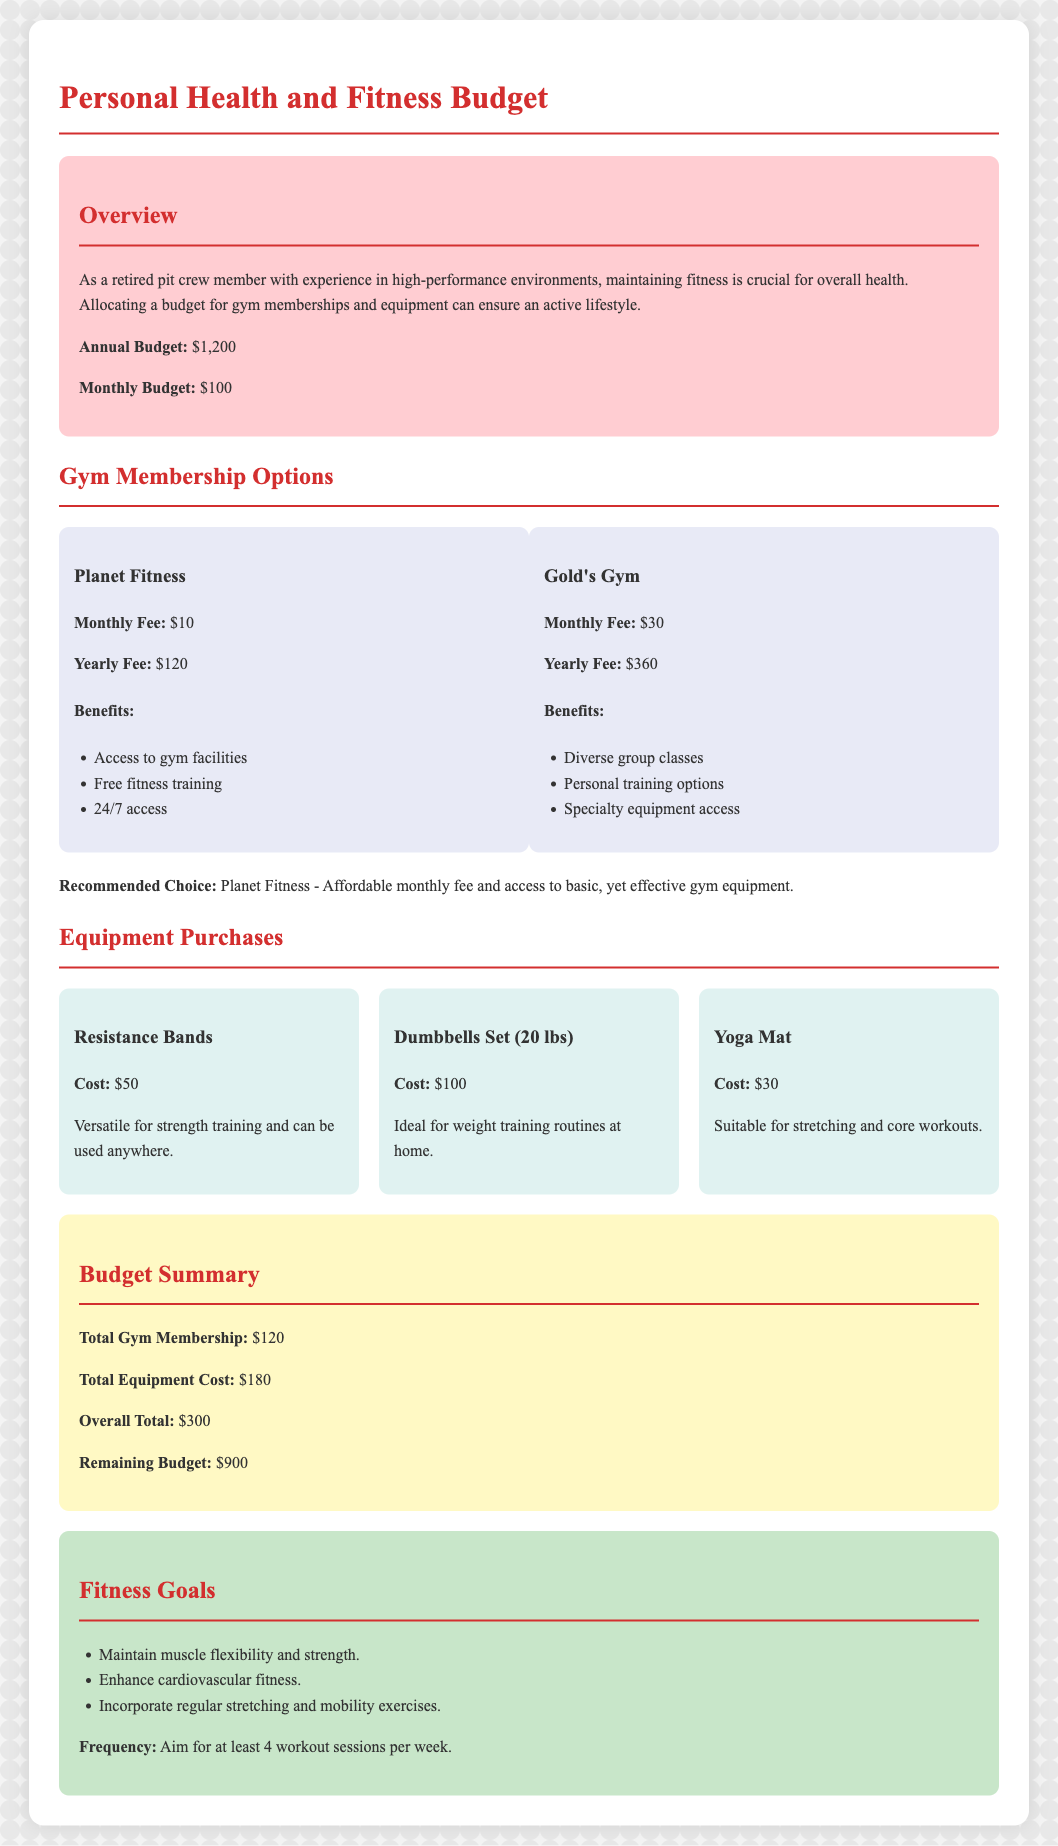What is the annual budget allocated for personal health and fitness? The annual budget is explicitly stated in the document as $1,200.
Answer: $1,200 What is the monthly gym membership fee for Planet Fitness? The document specifies that the monthly fee for Planet Fitness is $10.
Answer: $10 What is the total cost of equipment purchases? The total cost of the equipment purchases is summed up in the document as $180.
Answer: $180 What are the fitness goals mentioned in the document? The document lists three fitness goals, focusing on flexibility, cardiovascular fitness, and regular exercises.
Answer: Maintain muscle flexibility and strength, enhance cardiovascular fitness, incorporate regular stretching and mobility exercises Which gym has a higher annual fee? The document states the yearly fee for Gold's Gym is $360, compared to Planet Fitness's $120.
Answer: Gold's Gym What is the total gym membership cost? The total gym membership cost is provided in the budget summary section as $120.
Answer: $120 What is the remaining budget after gym membership and equipment purchases? The document summarizes the remaining budget as $900 after deducting expenses.
Answer: $900 What is the monthly budget allocated for personal health and fitness? The document states the monthly budget as $100.
Answer: $100 What is the cost of the Yoga Mat? The document specifies the cost of the Yoga Mat as $30.
Answer: $30 